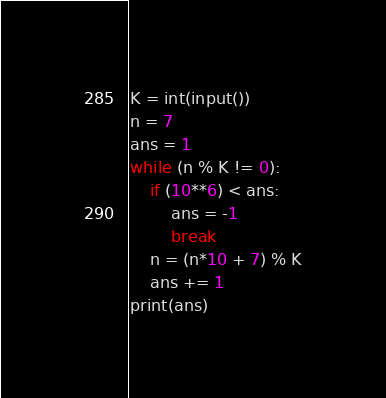<code> <loc_0><loc_0><loc_500><loc_500><_Python_>K = int(input())
n = 7
ans = 1
while (n % K != 0):
    if (10**6) < ans:
        ans = -1
        break
    n = (n*10 + 7) % K
    ans += 1
print(ans)
</code> 